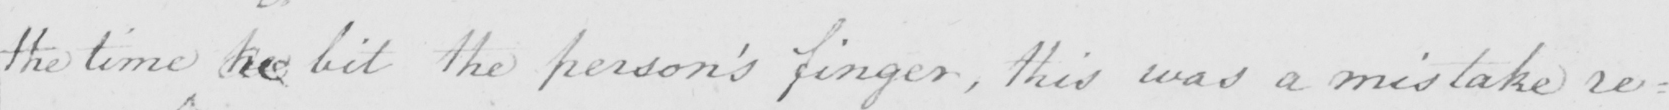What is written in this line of handwriting? the time he bit the person ' s finger , this was a mistake re= 